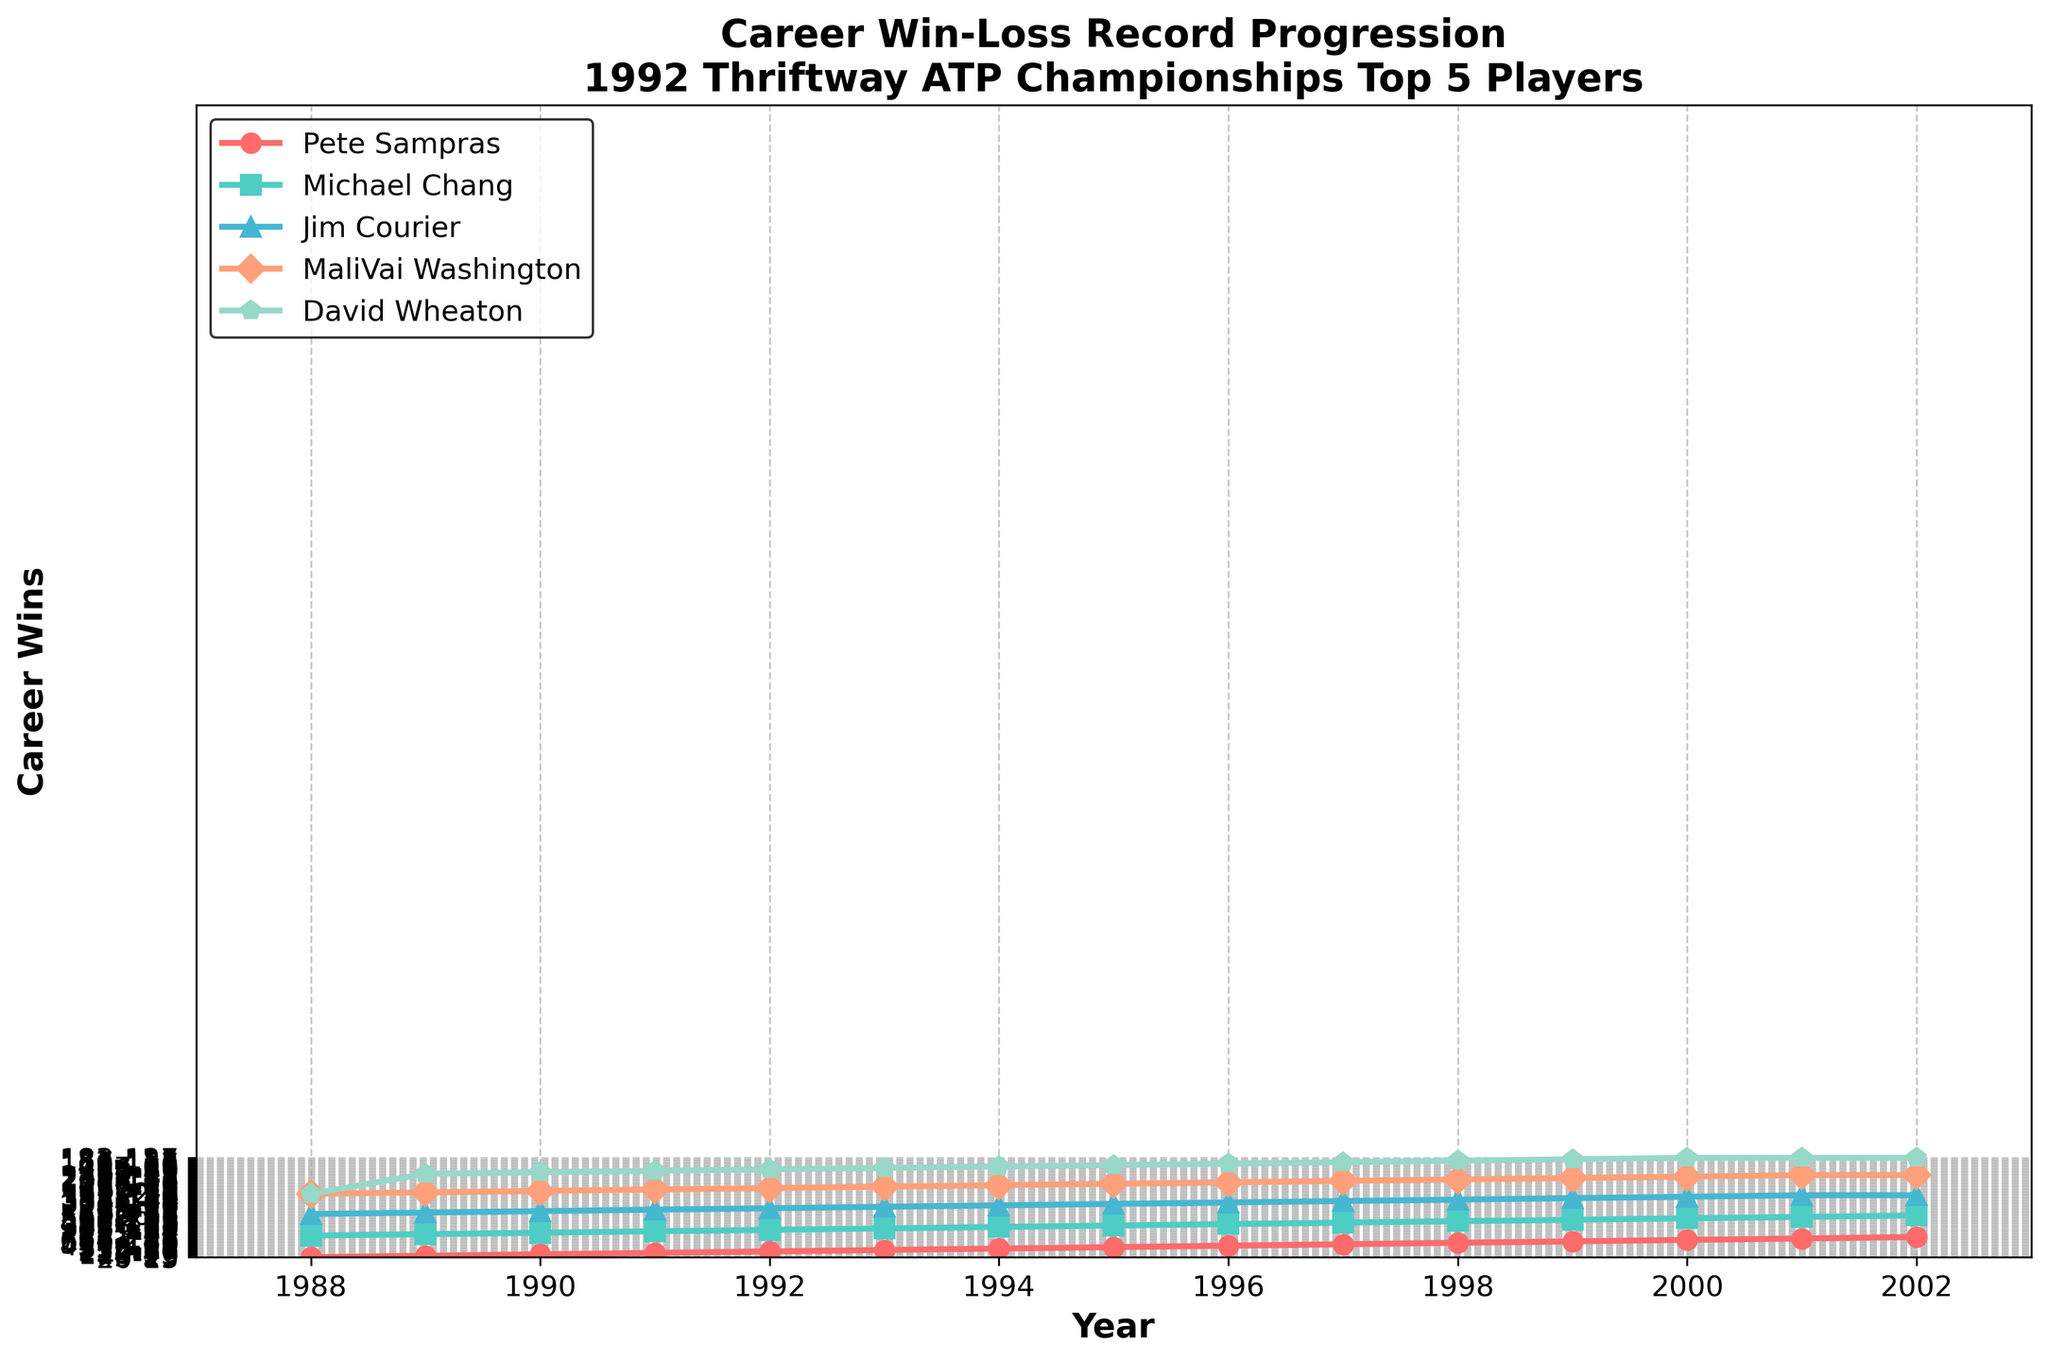Who had the highest career win-total in 1994? Look at the data points from 1994, the player with the highest win-total is Pete Sampras with 272 wins.
Answer: Pete Sampras Between 1991 and 1993, who had a larger increase in career wins: Michael Chang or Jim Courier? For Michael Chang, the increase is from 171 to 265 (265 - 171 = 94). For Jim Courier, the increase is from 107 to 203 (203 - 107 = 96). Comparison shows that Jim Courier had a larger increase.
Answer: Jim Courier How many career wins did David Wheaton have in 2002? Refer to the data point corresponding to David Wheaton in 2002, which shows 183 career wins.
Answer: 183 In what year did MaliVai Washington first reach at least 200 career wins? Checking the data, MaliVai Washington reached 205 career wins in 1997, which is the first year he crossed the 200-win mark.
Answer: 1997 Which player showed the most consistent improvement in their career win-total each year until 1996? By observing the annual increments for each player, it appears that Pete Sampras showed consistent improvement in career wins year-over-year until 1996.
Answer: Pete Sampras What is the difference in career wins between Pete Sampras and Michael Chang in 2000? In 2000, Pete Sampras had 632 wins, and Michael Chang had 536. The difference is 632 - 536 = 96.
Answer: 96 Who had the slowest growth rate of career wins after 1995 among the top 5 players? Assessing the data, David Wheaton's career win-total shows the least change after 1995, indicating the slowest growth.
Answer: David Wheaton Which two players had the closest career win-total in 1999? Looking at the 1999 data, MaliVai Washington and David Wheaton had career win-totals of 233 and 181 respectively. While they differ, these two players’ win-totals were relatively closer compared to others.
Answer: MaliVai Washington and David Wheaton By how much did Pete Sampras's career win-total increase between 1988 and 2002? Pete Sampras's career win-total in 1988 was 20 wins and in 2002 it was 762 wins. The increase is 762 - 20 = 742.
Answer: 742 How many total combined career wins did the top 5 players accumulate by 1996? Adding up the 1996 win-totals for all five players: Pete Sampras (396), Michael Chang (391), Jim Courier (307), MaliVai Washington (186), and David Wheaton (159) gives 396 + 391 + 307 + 186 + 159 = 1439.
Answer: 1439 